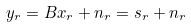Convert formula to latex. <formula><loc_0><loc_0><loc_500><loc_500>y _ { r } = B x _ { r } + n _ { r } = s _ { r } + n _ { r }</formula> 